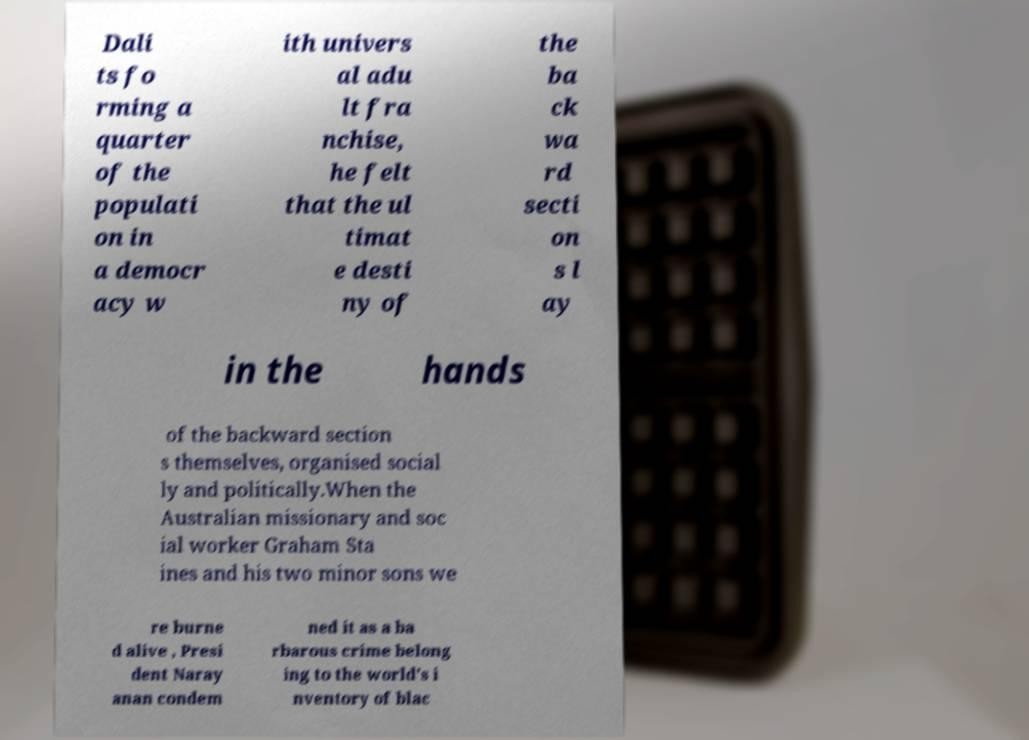Can you read and provide the text displayed in the image?This photo seems to have some interesting text. Can you extract and type it out for me? Dali ts fo rming a quarter of the populati on in a democr acy w ith univers al adu lt fra nchise, he felt that the ul timat e desti ny of the ba ck wa rd secti on s l ay in the hands of the backward section s themselves, organised social ly and politically.When the Australian missionary and soc ial worker Graham Sta ines and his two minor sons we re burne d alive , Presi dent Naray anan condem ned it as a ba rbarous crime belong ing to the world's i nventory of blac 